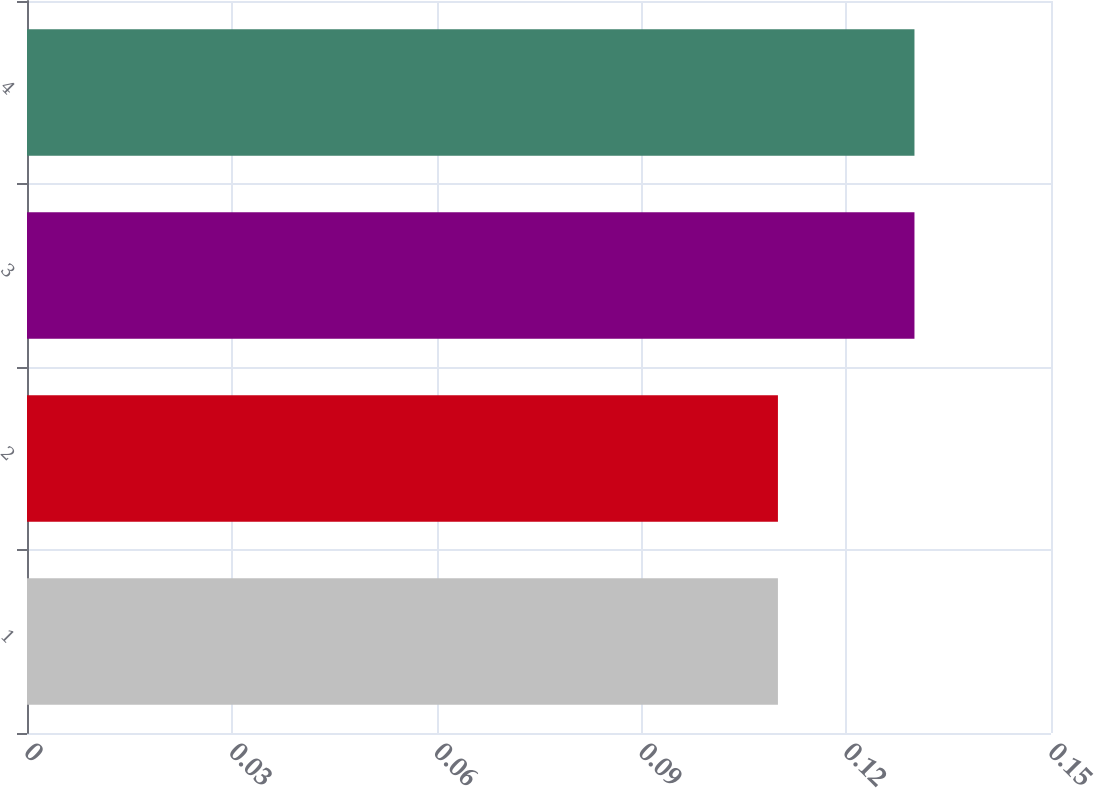Convert chart. <chart><loc_0><loc_0><loc_500><loc_500><bar_chart><fcel>1<fcel>2<fcel>3<fcel>4<nl><fcel>0.11<fcel>0.11<fcel>0.13<fcel>0.13<nl></chart> 